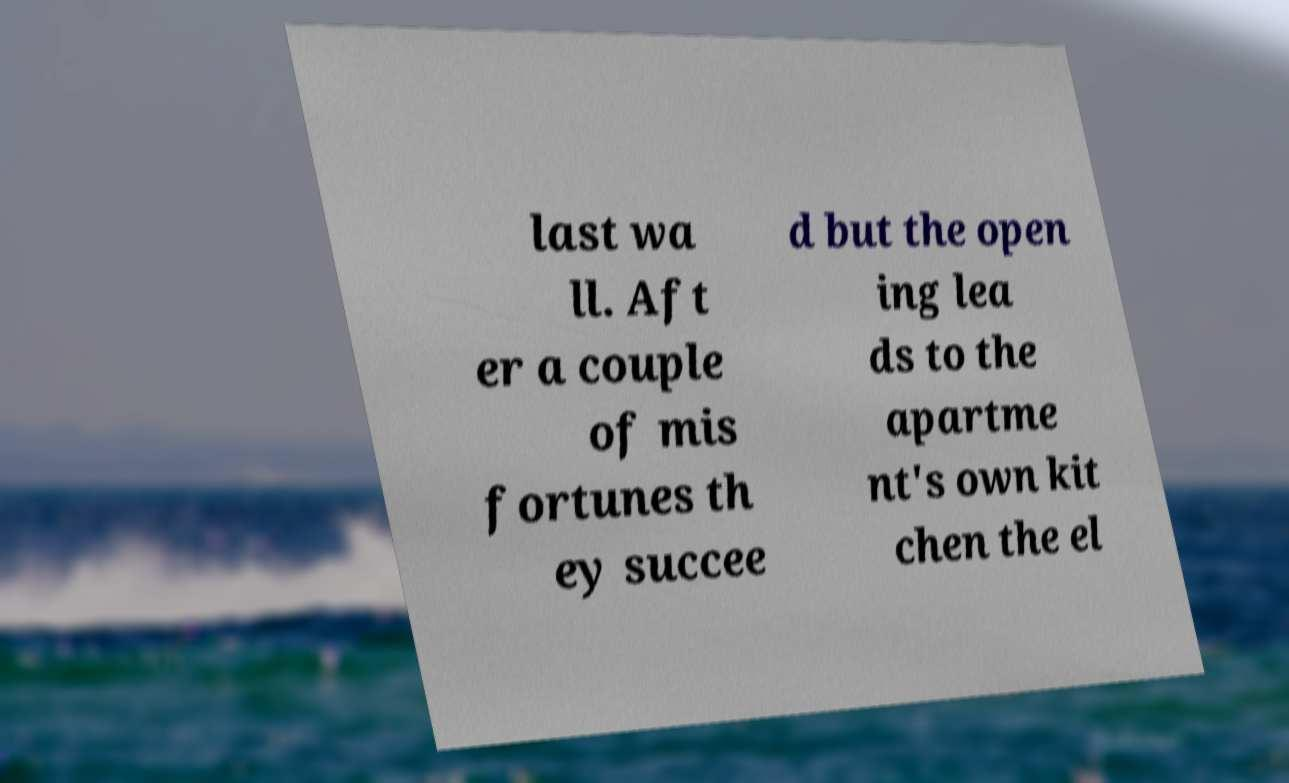Please identify and transcribe the text found in this image. last wa ll. Aft er a couple of mis fortunes th ey succee d but the open ing lea ds to the apartme nt's own kit chen the el 